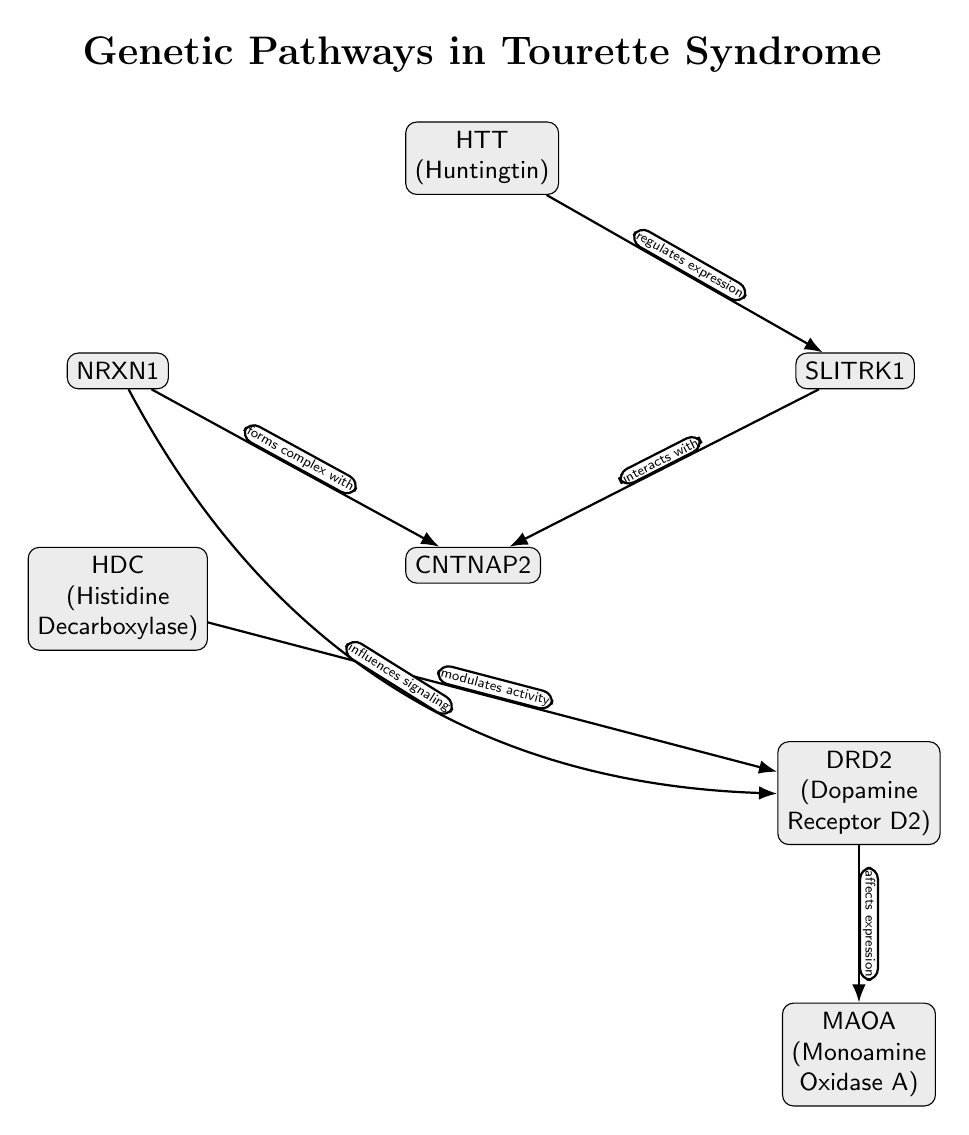What is the first node in the diagram? The first node in the diagram represents "HTT (Huntingtin)", which is positioned at the top as the starting point of the genetic pathways involved in Tourette Syndrome.
Answer: HTT (Huntingtin) How many nodes are present in the diagram? The diagram contains a total of six nodes: HTT, SLITRK1, NRXN1, HDC, CNTNAP2, DRD2, and MAOA. Counting each one results in six nodes overall.
Answer: 6 What type of relationship exists between HTT and SLITRK1? The diagram specifies that HTT "regulates expression" of SLITRK1, indicating a functional relationship where one influences the expression of the other.
Answer: regulates expression Which two nodes interact with CNTNAP2? The nodes that interact with CNTNAP2 are SLITRK1 and NRXN1, as indicated by the arrows showing their relationships with CNTNAP2 in the diagram.
Answer: SLITRK1 and NRXN1 What effect does HDC have on DRD2? HDC is indicated to "modulates activity" of DRD2 in the diagram. This suggests that HDC influences the functionality or performance of DRD2.
Answer: modulates activity What common function is suggested by the edge labeled "influences signaling"? This edge indicates that NRXN1 impacts the signaling processes related to DRD2, implying that NRXN1 is involved in signaling pathways affecting DRD2's role in Tourette Syndrome.
Answer: influences signaling Which gene is positioned last in the pathway? The last gene in the pathway, according to the diagram, is MAOA (Monoamine Oxidase A), as it is located at the bottom end of the node arrangement.
Answer: MAOA (Monoamine Oxidase A) How does DRD2 relate to MAOA in the diagram? The relationship depicted in the diagram shows that DRD2 "affects expression" of MAOA, indicating a direct influence of DRD2 on the expression level of MAOA.
Answer: affects expression 